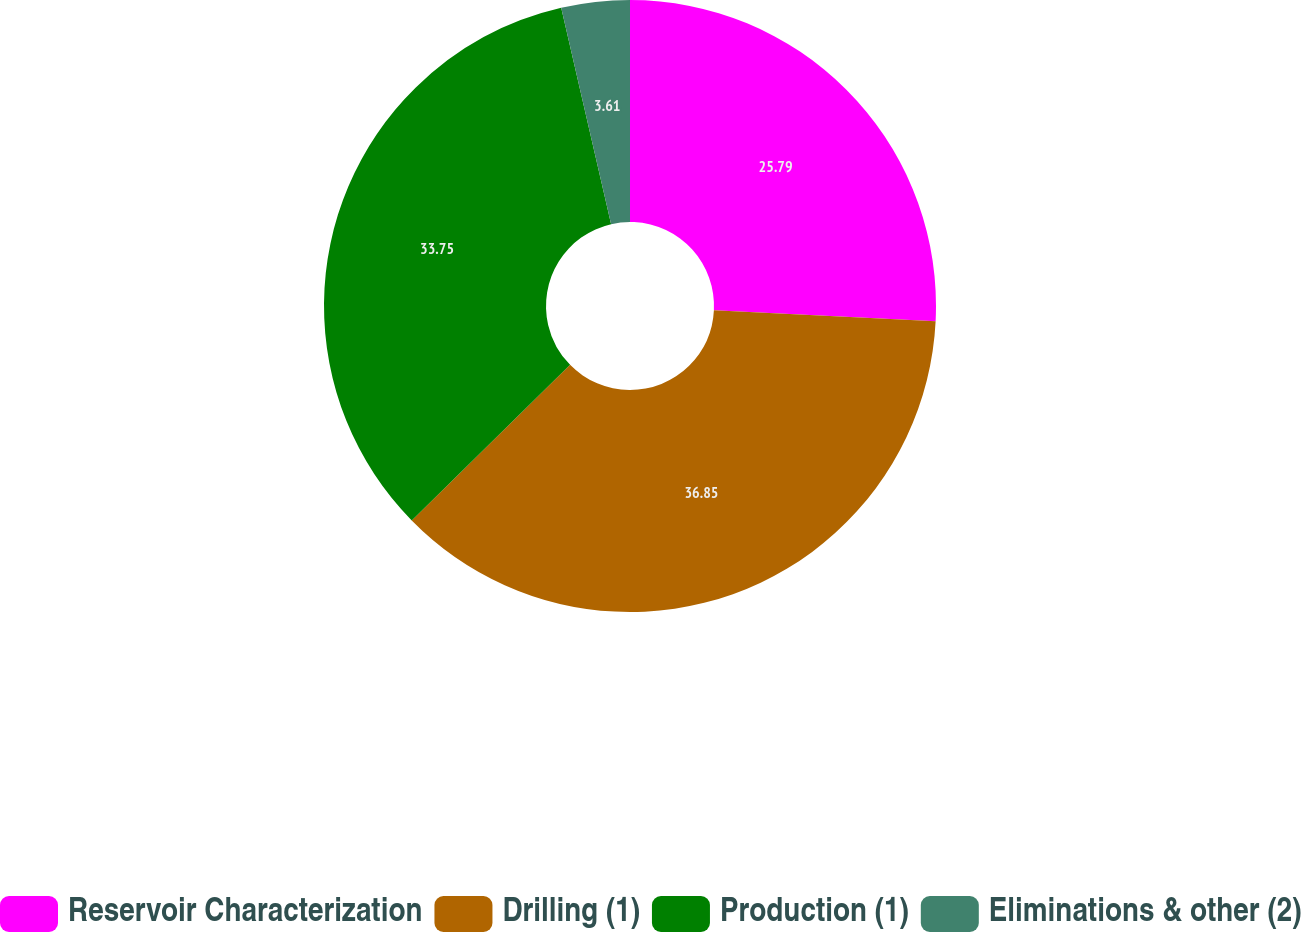<chart> <loc_0><loc_0><loc_500><loc_500><pie_chart><fcel>Reservoir Characterization<fcel>Drilling (1)<fcel>Production (1)<fcel>Eliminations & other (2)<nl><fcel>25.79%<fcel>36.85%<fcel>33.75%<fcel>3.61%<nl></chart> 